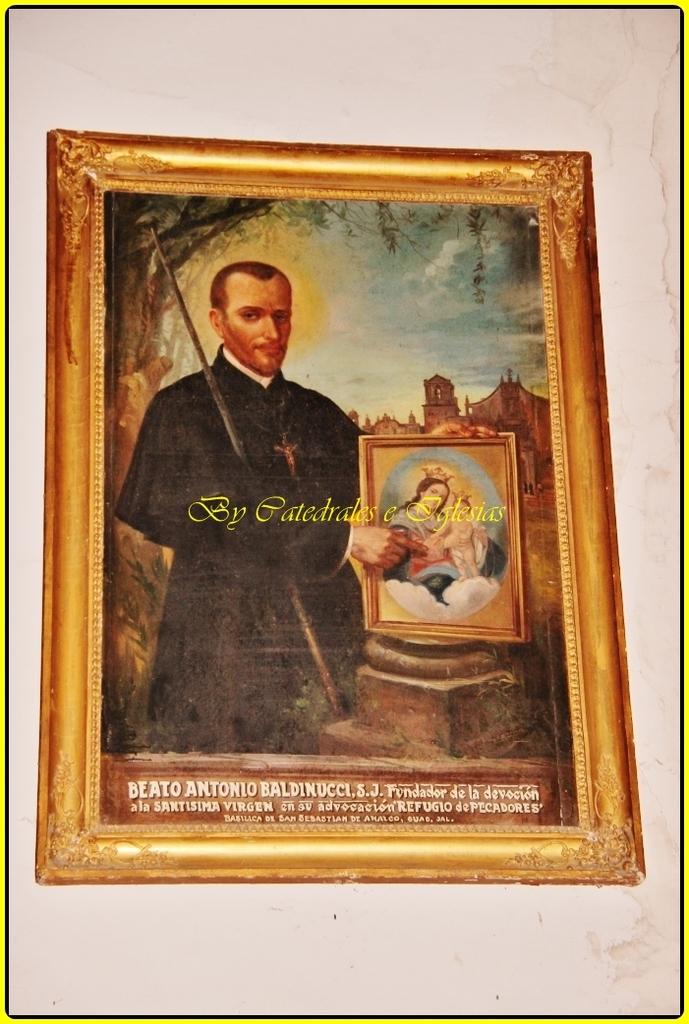Is this painting about antonio?
Offer a terse response. Yes. 